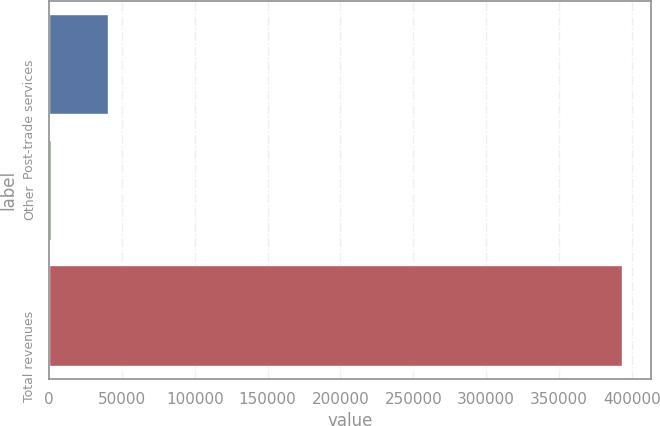<chart> <loc_0><loc_0><loc_500><loc_500><bar_chart><fcel>Post-trade services<fcel>Other<fcel>Total revenues<nl><fcel>40461.8<fcel>1244<fcel>393422<nl></chart> 